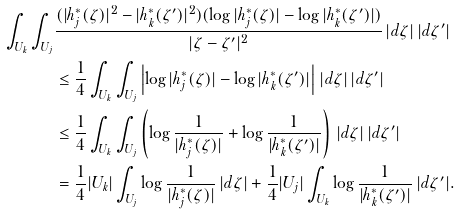<formula> <loc_0><loc_0><loc_500><loc_500>\int _ { U _ { k } } \int _ { U _ { j } } & \frac { ( | h _ { j } ^ { * } ( \zeta ) | ^ { 2 } - | h _ { k } ^ { * } ( \zeta ^ { \prime } ) | ^ { 2 } ) ( \log | h _ { j } ^ { * } ( \zeta ) | - \log | h _ { k } ^ { * } ( \zeta ^ { \prime } ) | ) } { | \zeta - \zeta ^ { \prime } | ^ { 2 } } \, | d \zeta | \, | d \zeta ^ { \prime } | \\ & \leq \frac { 1 } { 4 } \int _ { U _ { k } } \int _ { U _ { j } } \left | \log | h _ { j } ^ { * } ( \zeta ) | - \log | h _ { k } ^ { * } ( \zeta ^ { \prime } ) | \right | \, | d \zeta | \, | d \zeta ^ { \prime } | \\ & \leq \frac { 1 } { 4 } \int _ { U _ { k } } \int _ { U _ { j } } \left ( \log \frac { 1 } { | h _ { j } ^ { * } ( \zeta ) | } + \log \frac { 1 } { | h _ { k } ^ { * } ( \zeta ^ { \prime } ) | } \right ) \, | d \zeta | \, | d \zeta ^ { \prime } | \\ & = \frac { 1 } { 4 } | U _ { k } | \int _ { U _ { j } } \log \frac { 1 } { | h _ { j } ^ { * } ( \zeta ) | } \, | d \zeta | + \frac { 1 } { 4 } | U _ { j } | \int _ { U _ { k } } \log \frac { 1 } { | h _ { k } ^ { * } ( \zeta ^ { \prime } ) | } \, | d \zeta ^ { \prime } | .</formula> 